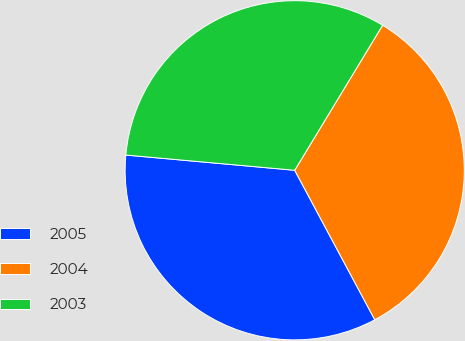Convert chart to OTSL. <chart><loc_0><loc_0><loc_500><loc_500><pie_chart><fcel>2005<fcel>2004<fcel>2003<nl><fcel>34.26%<fcel>33.5%<fcel>32.24%<nl></chart> 